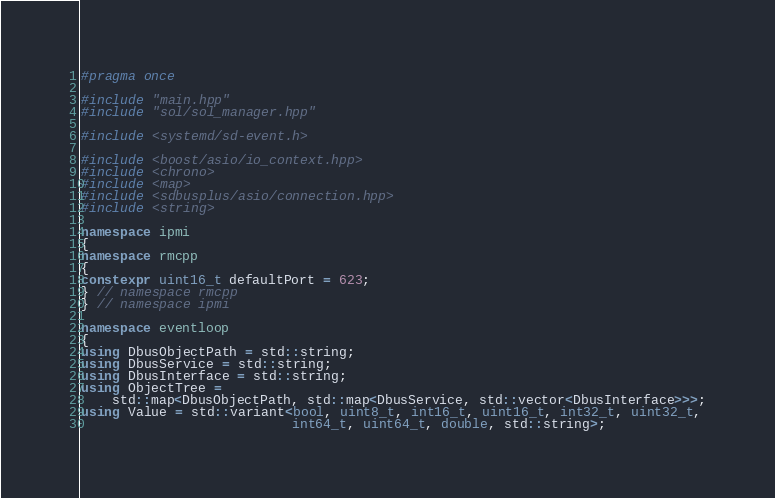Convert code to text. <code><loc_0><loc_0><loc_500><loc_500><_C++_>#pragma once

#include "main.hpp"
#include "sol/sol_manager.hpp"

#include <systemd/sd-event.h>

#include <boost/asio/io_context.hpp>
#include <chrono>
#include <map>
#include <sdbusplus/asio/connection.hpp>
#include <string>

namespace ipmi
{
namespace rmcpp
{
constexpr uint16_t defaultPort = 623;
} // namespace rmcpp
} // namespace ipmi

namespace eventloop
{
using DbusObjectPath = std::string;
using DbusService = std::string;
using DbusInterface = std::string;
using ObjectTree =
    std::map<DbusObjectPath, std::map<DbusService, std::vector<DbusInterface>>>;
using Value = std::variant<bool, uint8_t, int16_t, uint16_t, int32_t, uint32_t,
                           int64_t, uint64_t, double, std::string>;</code> 